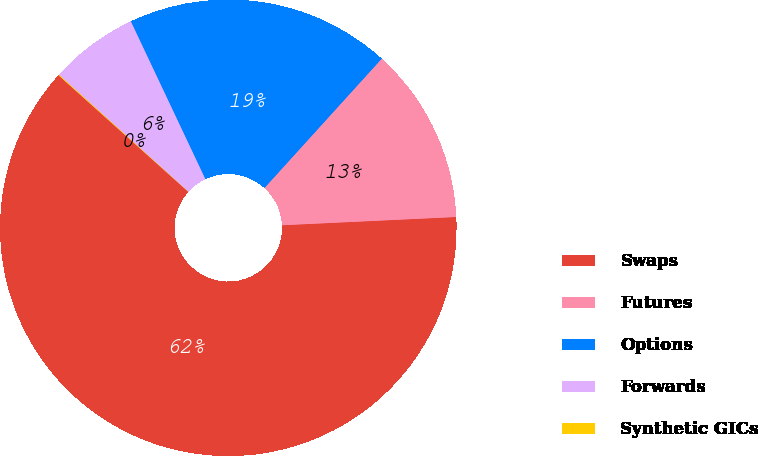<chart> <loc_0><loc_0><loc_500><loc_500><pie_chart><fcel>Swaps<fcel>Futures<fcel>Options<fcel>Forwards<fcel>Synthetic GICs<nl><fcel>62.4%<fcel>12.52%<fcel>18.75%<fcel>6.28%<fcel>0.05%<nl></chart> 